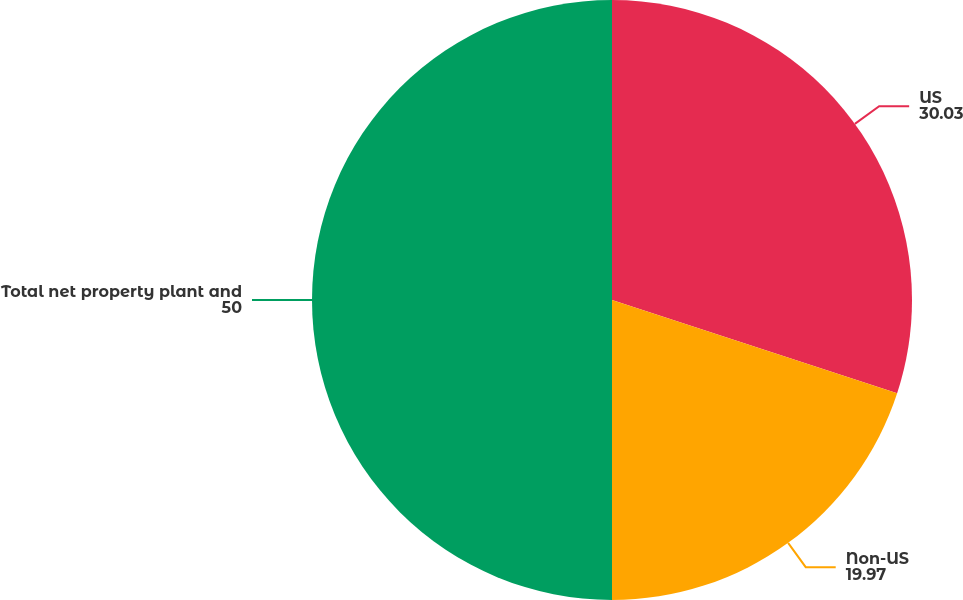<chart> <loc_0><loc_0><loc_500><loc_500><pie_chart><fcel>US<fcel>Non-US<fcel>Total net property plant and<nl><fcel>30.03%<fcel>19.97%<fcel>50.0%<nl></chart> 